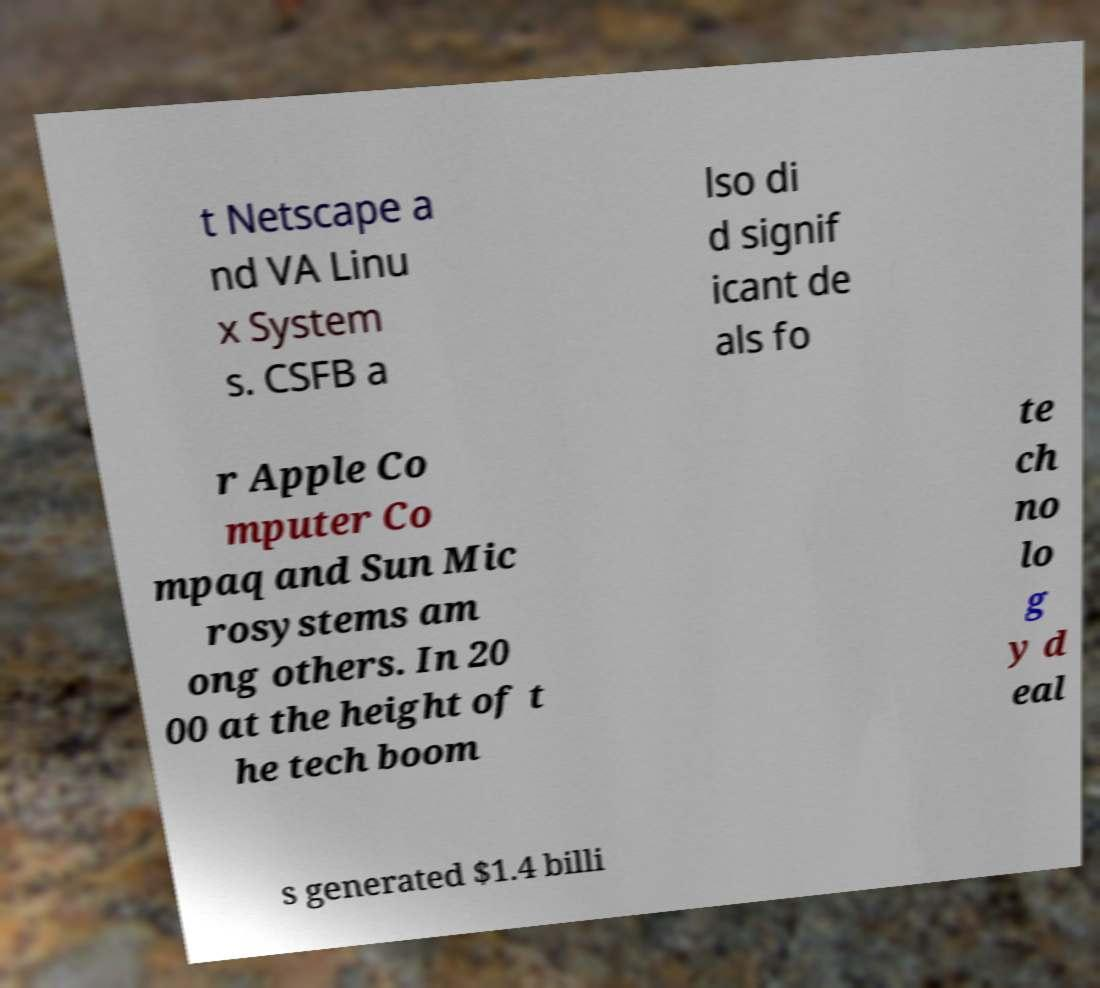For documentation purposes, I need the text within this image transcribed. Could you provide that? t Netscape a nd VA Linu x System s. CSFB a lso di d signif icant de als fo r Apple Co mputer Co mpaq and Sun Mic rosystems am ong others. In 20 00 at the height of t he tech boom te ch no lo g y d eal s generated $1.4 billi 